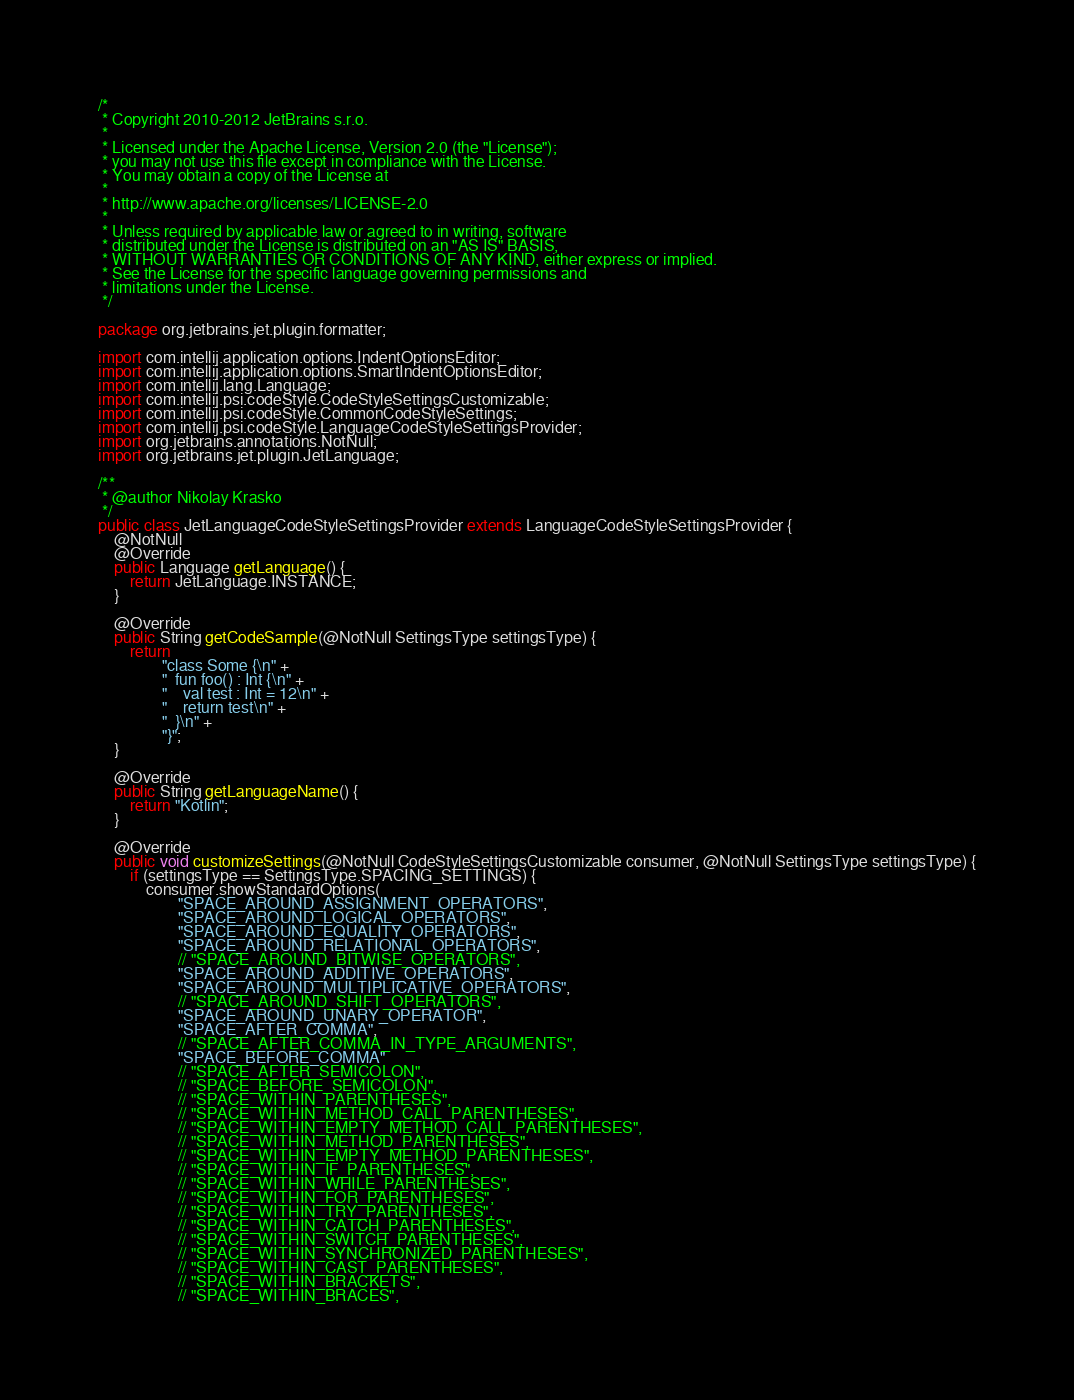Convert code to text. <code><loc_0><loc_0><loc_500><loc_500><_Java_>/*
 * Copyright 2010-2012 JetBrains s.r.o.
 *
 * Licensed under the Apache License, Version 2.0 (the "License");
 * you may not use this file except in compliance with the License.
 * You may obtain a copy of the License at
 *
 * http://www.apache.org/licenses/LICENSE-2.0
 *
 * Unless required by applicable law or agreed to in writing, software
 * distributed under the License is distributed on an "AS IS" BASIS,
 * WITHOUT WARRANTIES OR CONDITIONS OF ANY KIND, either express or implied.
 * See the License for the specific language governing permissions and
 * limitations under the License.
 */

package org.jetbrains.jet.plugin.formatter;

import com.intellij.application.options.IndentOptionsEditor;
import com.intellij.application.options.SmartIndentOptionsEditor;
import com.intellij.lang.Language;
import com.intellij.psi.codeStyle.CodeStyleSettingsCustomizable;
import com.intellij.psi.codeStyle.CommonCodeStyleSettings;
import com.intellij.psi.codeStyle.LanguageCodeStyleSettingsProvider;
import org.jetbrains.annotations.NotNull;
import org.jetbrains.jet.plugin.JetLanguage;

/**
 * @author Nikolay Krasko
 */
public class JetLanguageCodeStyleSettingsProvider extends LanguageCodeStyleSettingsProvider {
    @NotNull
    @Override
    public Language getLanguage() {
        return JetLanguage.INSTANCE;
    }

    @Override
    public String getCodeSample(@NotNull SettingsType settingsType) {
        return
                "class Some {\n" +
                "  fun foo() : Int {\n" +
                "    val test : Int = 12\n" +
                "    return test\n" +
                "  }\n" +
                "}";
    }

    @Override
    public String getLanguageName() {
        return "Kotlin";
    }

    @Override
    public void customizeSettings(@NotNull CodeStyleSettingsCustomizable consumer, @NotNull SettingsType settingsType) {
        if (settingsType == SettingsType.SPACING_SETTINGS) {
            consumer.showStandardOptions(
                    "SPACE_AROUND_ASSIGNMENT_OPERATORS",
                    "SPACE_AROUND_LOGICAL_OPERATORS",
                    "SPACE_AROUND_EQUALITY_OPERATORS",
                    "SPACE_AROUND_RELATIONAL_OPERATORS",
                    // "SPACE_AROUND_BITWISE_OPERATORS",
                    "SPACE_AROUND_ADDITIVE_OPERATORS",
                    "SPACE_AROUND_MULTIPLICATIVE_OPERATORS",
                    // "SPACE_AROUND_SHIFT_OPERATORS",
                    "SPACE_AROUND_UNARY_OPERATOR",
                    "SPACE_AFTER_COMMA",
                    // "SPACE_AFTER_COMMA_IN_TYPE_ARGUMENTS",
                    "SPACE_BEFORE_COMMA"
                    // "SPACE_AFTER_SEMICOLON",
                    // "SPACE_BEFORE_SEMICOLON",
                    // "SPACE_WITHIN_PARENTHESES",
                    // "SPACE_WITHIN_METHOD_CALL_PARENTHESES",
                    // "SPACE_WITHIN_EMPTY_METHOD_CALL_PARENTHESES",
                    // "SPACE_WITHIN_METHOD_PARENTHESES",
                    // "SPACE_WITHIN_EMPTY_METHOD_PARENTHESES",
                    // "SPACE_WITHIN_IF_PARENTHESES",
                    // "SPACE_WITHIN_WHILE_PARENTHESES",
                    // "SPACE_WITHIN_FOR_PARENTHESES",
                    // "SPACE_WITHIN_TRY_PARENTHESES",
                    // "SPACE_WITHIN_CATCH_PARENTHESES",
                    // "SPACE_WITHIN_SWITCH_PARENTHESES",
                    // "SPACE_WITHIN_SYNCHRONIZED_PARENTHESES",
                    // "SPACE_WITHIN_CAST_PARENTHESES",
                    // "SPACE_WITHIN_BRACKETS",
                    // "SPACE_WITHIN_BRACES",</code> 